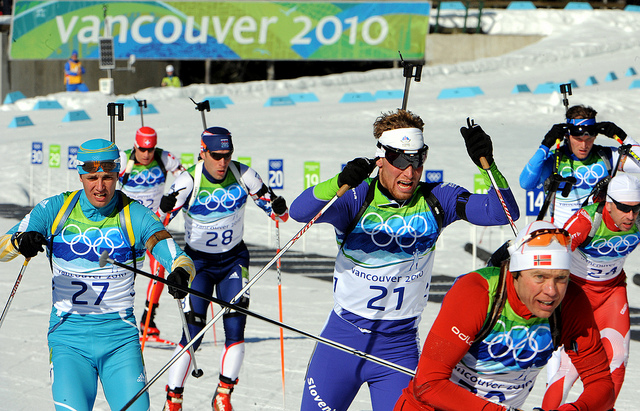Imagine you are a sports commentator. How would you describe this image to your audience? Ladies and gentlemen, what an exhilarating scene we have here at the Vancouver 2010 Winter Olympics ski race! Watch closely as our athletes, donned in their vibrant team colors and state-of-the-art gear, forge ahead with unmatched velocity and precision. Look at the intensity in their eyes, even shielded by their high-tech goggles and sunglasses, designed to battle the glare of the sun reflecting off the snow. Notice the synchronicity in their movements as they wield their ski poles, propelling themselves through this grueling course. Each headband and ski boot is not just a piece of equipment, but a testament to the rigorous training and unyielding spirit that embodies every competitor here today. This is more than a race; this is a showcase of human endurance, skill, and the relentless pursuit of excellence. Hold your breath, folks, as every second counts and history is being written in the white canvas of this snowy arena. What strategies might these athletes be using to win the race? The athletes are likely employing several strategies to maximize their performance and increase their chances of winning this race. Firstly, precision in technique is crucial—they would have spent countless hours perfecting their skiing form to minimize drag and maintain speed. Drafting behind other competitors to conserve energy and then making a strategic pass at the right moment is a common tactic. Nutritional optimization ensures they have the endurance needed for high performance. Mental resilience is built through rigorous psychological training, helping them stay focused under the immense pressure of the Olympics. Knowing the course well allows them to navigate tricky sections with agility. Additionally, their equipment is meticulously chosen and maintained to provide them with the best possible advantage. Listening to real-time feedback from their coaches can help them make quick adjustments mid-race. All these elements combined form a comprehensive strategy to achieve Olympic glory. 